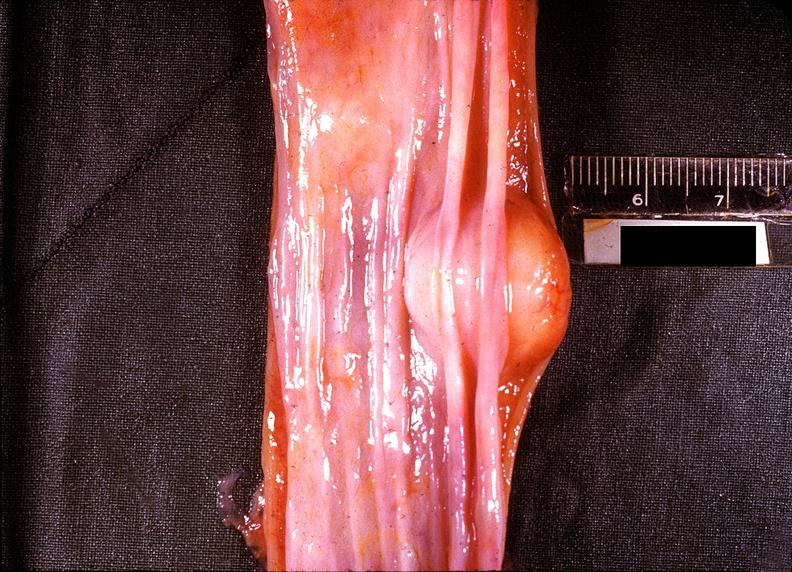what does this image show?
Answer the question using a single word or phrase. Esophagus 